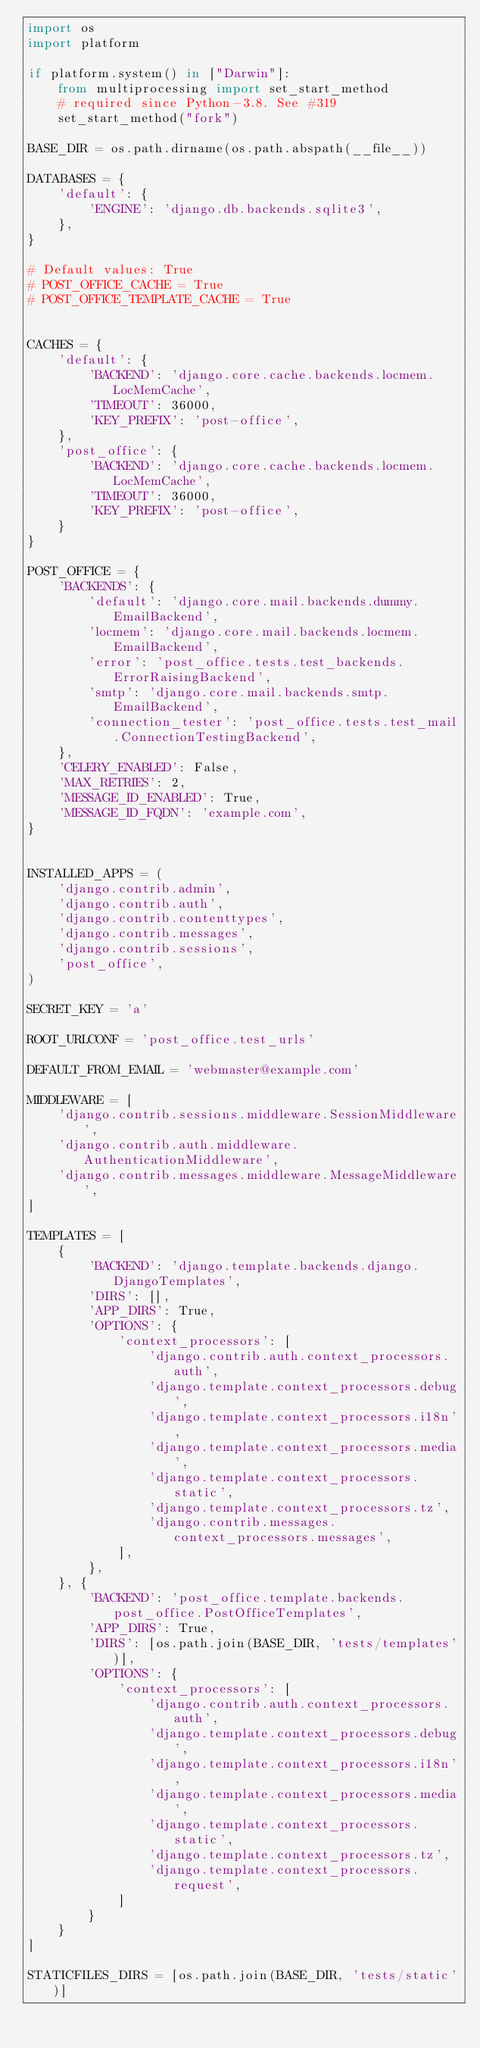<code> <loc_0><loc_0><loc_500><loc_500><_Python_>import os
import platform

if platform.system() in ["Darwin"]:
    from multiprocessing import set_start_method
    # required since Python-3.8. See #319
    set_start_method("fork")

BASE_DIR = os.path.dirname(os.path.abspath(__file__))

DATABASES = {
    'default': {
        'ENGINE': 'django.db.backends.sqlite3',
    },
}

# Default values: True
# POST_OFFICE_CACHE = True
# POST_OFFICE_TEMPLATE_CACHE = True


CACHES = {
    'default': {
        'BACKEND': 'django.core.cache.backends.locmem.LocMemCache',
        'TIMEOUT': 36000,
        'KEY_PREFIX': 'post-office',
    },
    'post_office': {
        'BACKEND': 'django.core.cache.backends.locmem.LocMemCache',
        'TIMEOUT': 36000,
        'KEY_PREFIX': 'post-office',
    }
}

POST_OFFICE = {
    'BACKENDS': {
        'default': 'django.core.mail.backends.dummy.EmailBackend',
        'locmem': 'django.core.mail.backends.locmem.EmailBackend',
        'error': 'post_office.tests.test_backends.ErrorRaisingBackend',
        'smtp': 'django.core.mail.backends.smtp.EmailBackend',
        'connection_tester': 'post_office.tests.test_mail.ConnectionTestingBackend',
    },
    'CELERY_ENABLED': False,
    'MAX_RETRIES': 2,
    'MESSAGE_ID_ENABLED': True,
    'MESSAGE_ID_FQDN': 'example.com',
}


INSTALLED_APPS = (
    'django.contrib.admin',
    'django.contrib.auth',
    'django.contrib.contenttypes',
    'django.contrib.messages',
    'django.contrib.sessions',
    'post_office',
)

SECRET_KEY = 'a'

ROOT_URLCONF = 'post_office.test_urls'

DEFAULT_FROM_EMAIL = 'webmaster@example.com'

MIDDLEWARE = [
    'django.contrib.sessions.middleware.SessionMiddleware',
    'django.contrib.auth.middleware.AuthenticationMiddleware',
    'django.contrib.messages.middleware.MessageMiddleware',
]

TEMPLATES = [
    {
        'BACKEND': 'django.template.backends.django.DjangoTemplates',
        'DIRS': [],
        'APP_DIRS': True,
        'OPTIONS': {
            'context_processors': [
                'django.contrib.auth.context_processors.auth',
                'django.template.context_processors.debug',
                'django.template.context_processors.i18n',
                'django.template.context_processors.media',
                'django.template.context_processors.static',
                'django.template.context_processors.tz',
                'django.contrib.messages.context_processors.messages',
            ],
        },
    }, {
        'BACKEND': 'post_office.template.backends.post_office.PostOfficeTemplates',
        'APP_DIRS': True,
        'DIRS': [os.path.join(BASE_DIR, 'tests/templates')],
        'OPTIONS': {
            'context_processors': [
                'django.contrib.auth.context_processors.auth',
                'django.template.context_processors.debug',
                'django.template.context_processors.i18n',
                'django.template.context_processors.media',
                'django.template.context_processors.static',
                'django.template.context_processors.tz',
                'django.template.context_processors.request',
            ]
        }
    }
]

STATICFILES_DIRS = [os.path.join(BASE_DIR, 'tests/static')]
</code> 